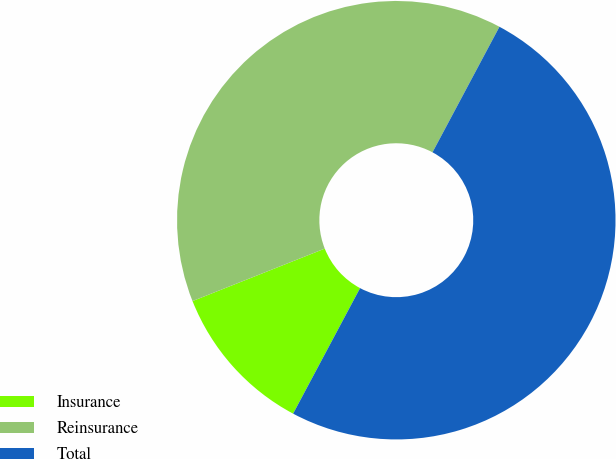Convert chart. <chart><loc_0><loc_0><loc_500><loc_500><pie_chart><fcel>Insurance<fcel>Reinsurance<fcel>Total<nl><fcel>11.19%<fcel>38.81%<fcel>50.0%<nl></chart> 